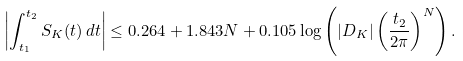Convert formula to latex. <formula><loc_0><loc_0><loc_500><loc_500>\left | \int _ { t _ { 1 } } ^ { t _ { 2 } } S _ { K } ( t ) \, d t \right | \leq 0 . 2 6 4 + 1 . 8 4 3 N + 0 . 1 0 5 \log \left ( | D _ { K } | \left ( \frac { t _ { 2 } } { 2 \pi } \right ) ^ { N } \right ) .</formula> 